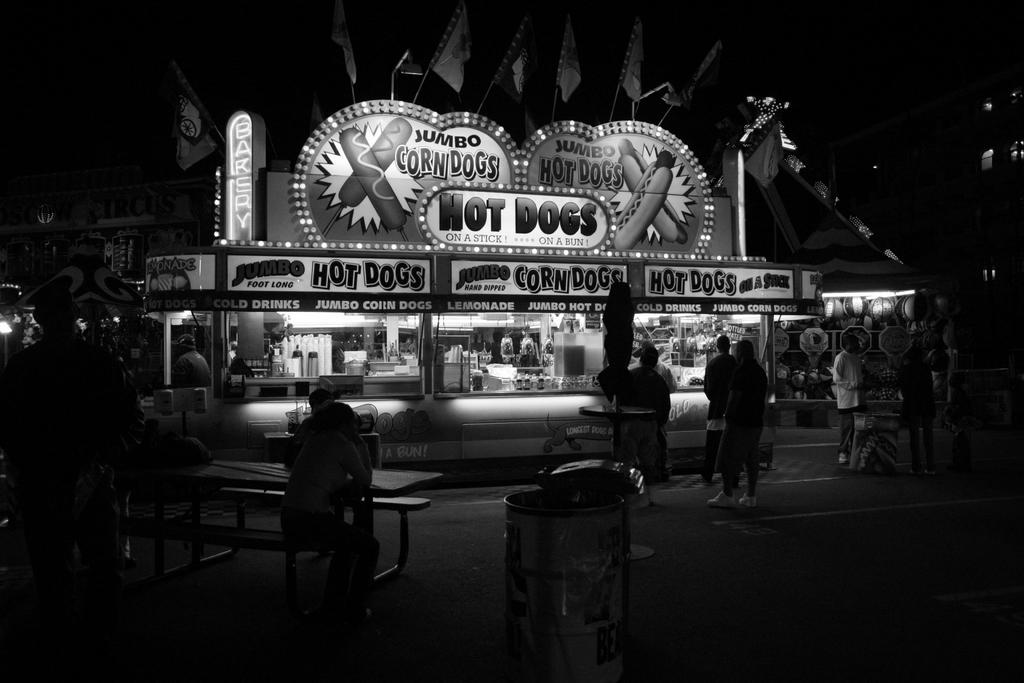<image>
Summarize the visual content of the image. A stand with the word Hot Dogs written on it 